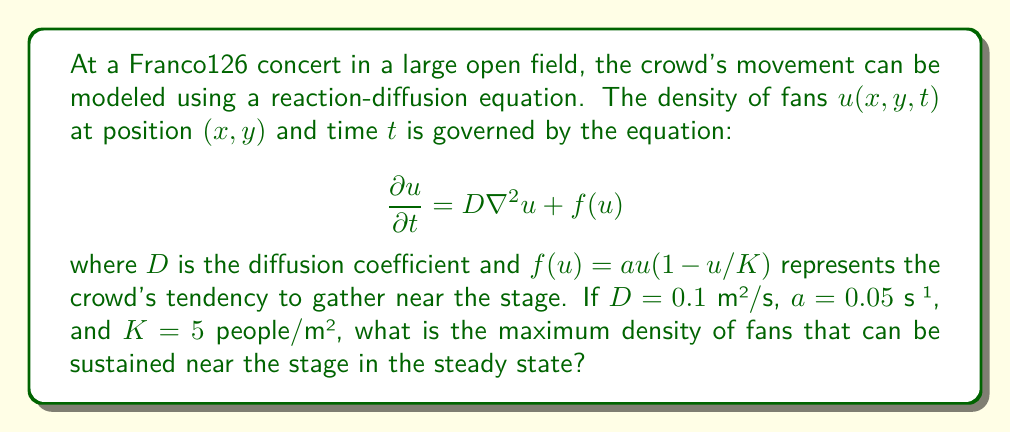Can you solve this math problem? To solve this problem, we need to follow these steps:

1) In the steady state, the crowd density doesn't change with time, so $\frac{\partial u}{\partial t} = 0$.

2) The equation then becomes:

   $$0 = D\nabla^2u + f(u)$$

3) Near the stage, we can assume the density is uniform, so $\nabla^2u = 0$.

4) This simplifies our equation to:

   $$0 = f(u) = au(1-u/K)$$

5) Solving this equation:
   
   $$au(1-u/K) = 0$$
   
   This is satisfied when $u=0$ or $u=K$.

6) Since we're looking for the maximum density, $u=K$ is our solution.

7) We're given that $K=5$ people/m².

Therefore, the maximum sustainable density near the stage is 5 people/m².
Answer: $5$ people/m² 